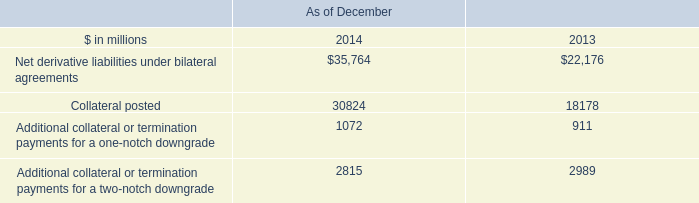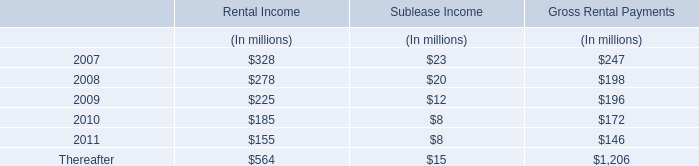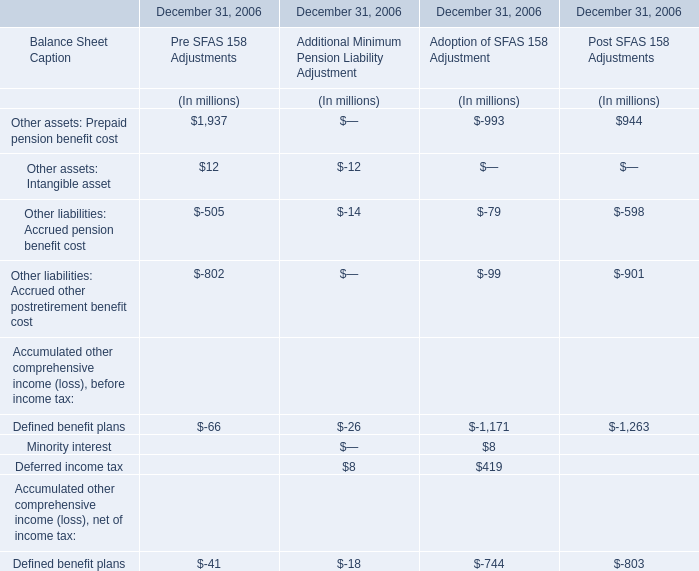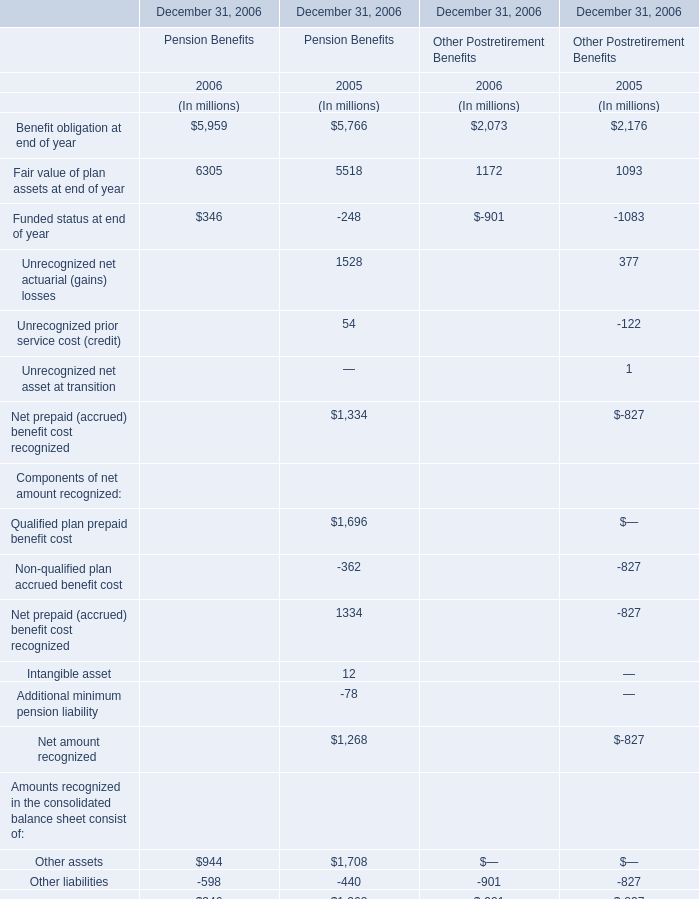What was the average of the Other liabilities in the years where Net prepaid (accrued) benefit cost recognized for Pension Benefits is positive? (in million) 
Computations: ((-440 - 827) / 2)
Answer: -633.5. 